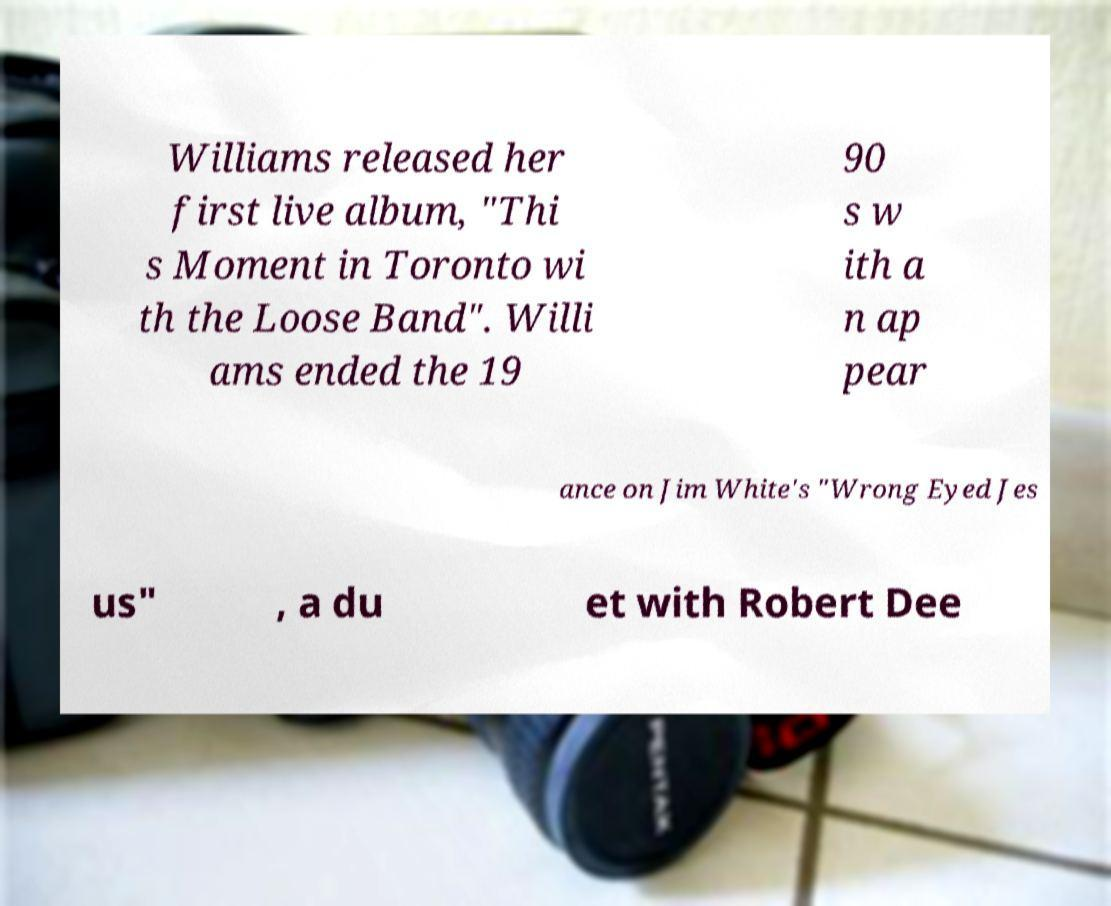Please read and relay the text visible in this image. What does it say? Williams released her first live album, "Thi s Moment in Toronto wi th the Loose Band". Willi ams ended the 19 90 s w ith a n ap pear ance on Jim White's "Wrong Eyed Jes us" , a du et with Robert Dee 